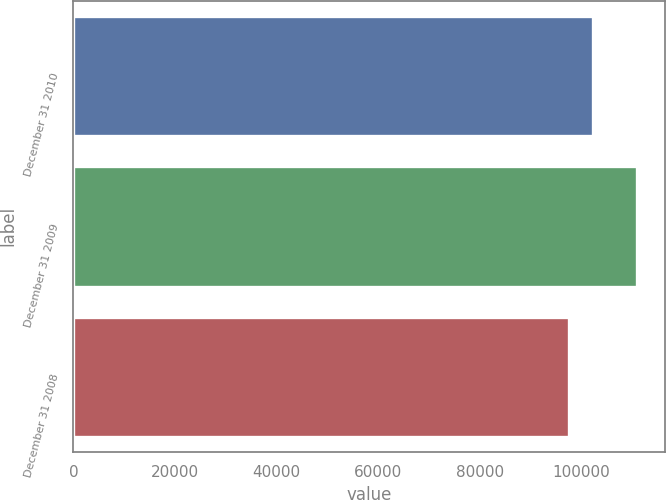Convert chart. <chart><loc_0><loc_0><loc_500><loc_500><bar_chart><fcel>December 31 2010<fcel>December 31 2009<fcel>December 31 2008<nl><fcel>102200<fcel>110860<fcel>97441<nl></chart> 